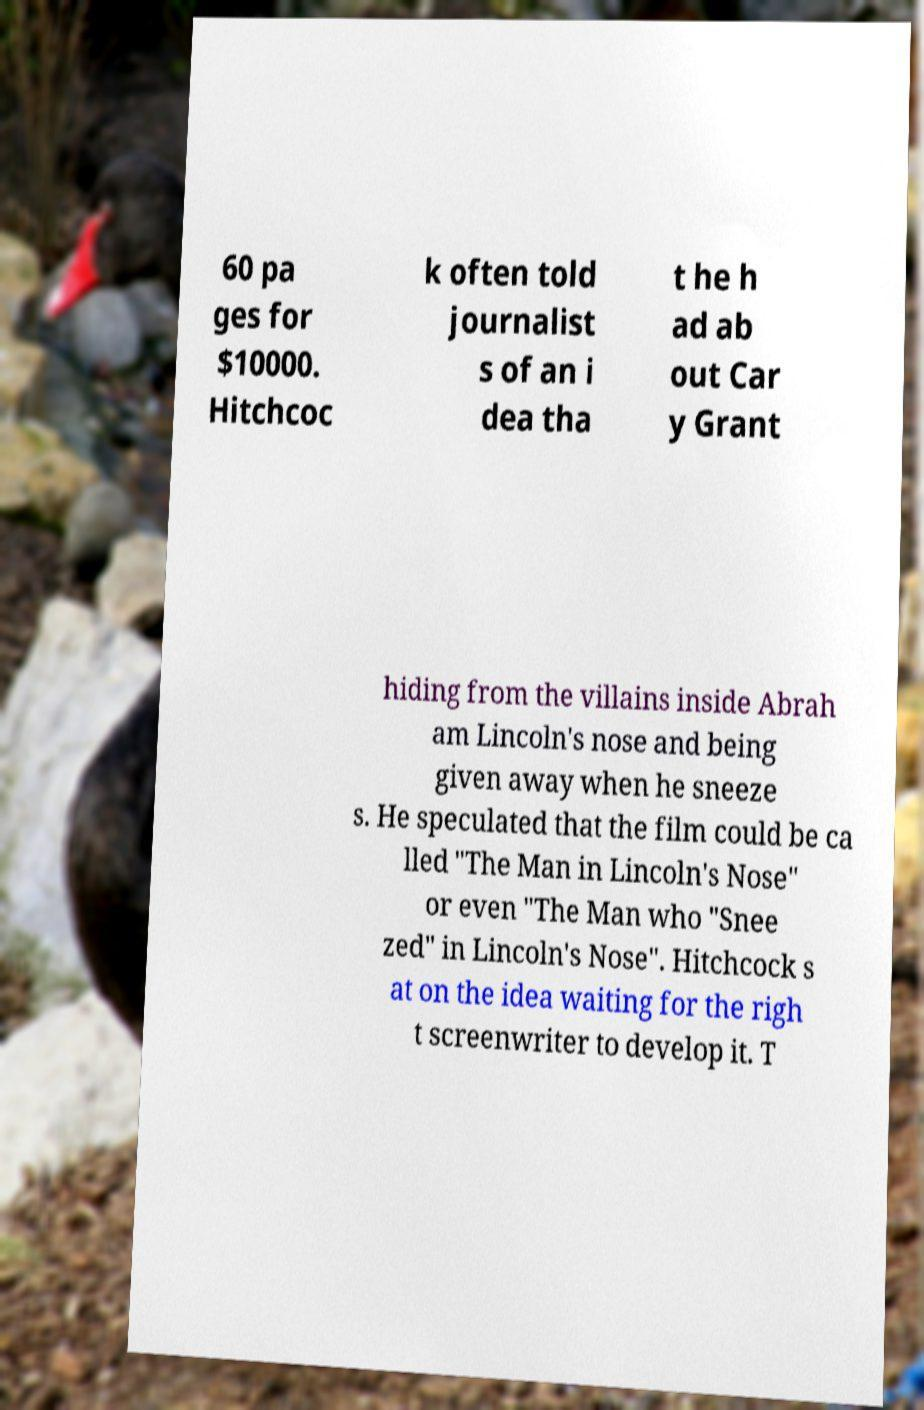Please read and relay the text visible in this image. What does it say? 60 pa ges for $10000. Hitchcoc k often told journalist s of an i dea tha t he h ad ab out Car y Grant hiding from the villains inside Abrah am Lincoln's nose and being given away when he sneeze s. He speculated that the film could be ca lled "The Man in Lincoln's Nose" or even "The Man who "Snee zed" in Lincoln's Nose". Hitchcock s at on the idea waiting for the righ t screenwriter to develop it. T 